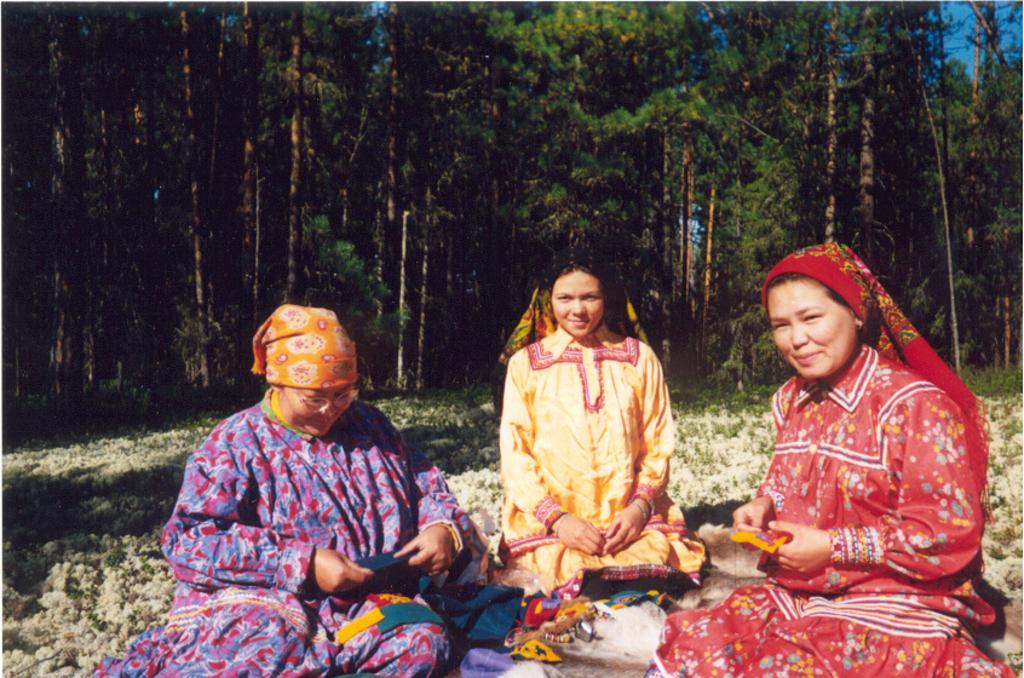What are the people in the image doing? The persons sitting in the center of the image are smiling. What can be seen in the background of the image? There are trees in the background of the image. What type of vegetation is on the ground in the image? There is grass on the ground in the image. Can you tell me how many pears are being held by the persons in the image? There are no pears present in the image; the persons are not holding any fruit. What type of stick is being used by the expert in the image? There is no expert or stick present in the image. 